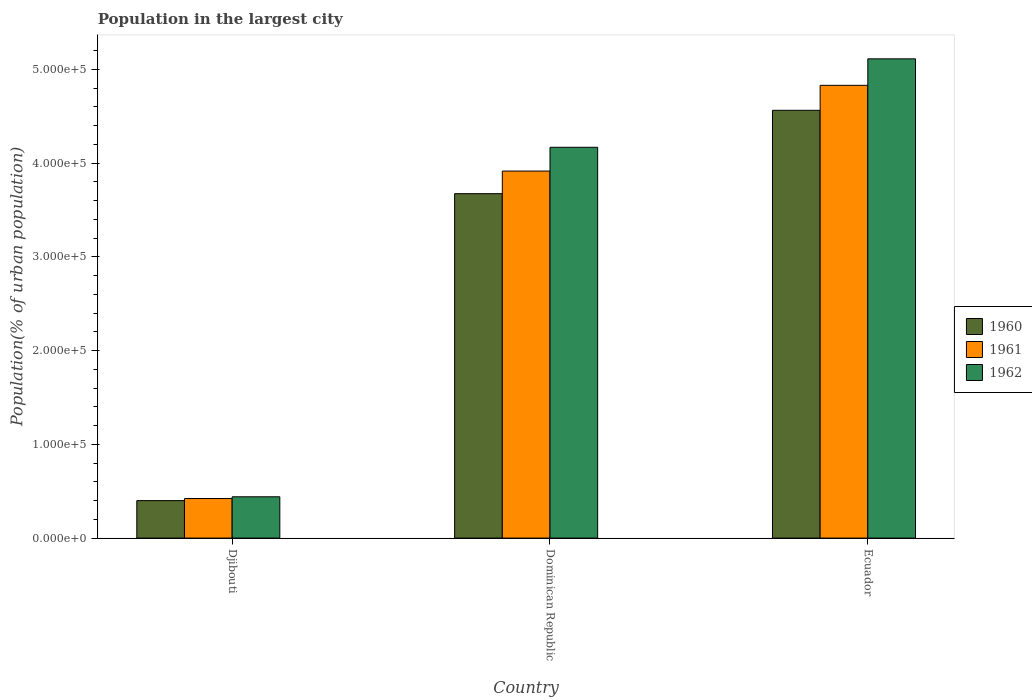How many different coloured bars are there?
Offer a terse response. 3. How many bars are there on the 3rd tick from the left?
Offer a terse response. 3. How many bars are there on the 2nd tick from the right?
Keep it short and to the point. 3. What is the label of the 1st group of bars from the left?
Provide a short and direct response. Djibouti. What is the population in the largest city in 1960 in Dominican Republic?
Ensure brevity in your answer.  3.67e+05. Across all countries, what is the maximum population in the largest city in 1960?
Give a very brief answer. 4.56e+05. Across all countries, what is the minimum population in the largest city in 1960?
Provide a short and direct response. 4.00e+04. In which country was the population in the largest city in 1962 maximum?
Make the answer very short. Ecuador. In which country was the population in the largest city in 1962 minimum?
Provide a succinct answer. Djibouti. What is the total population in the largest city in 1960 in the graph?
Keep it short and to the point. 8.64e+05. What is the difference between the population in the largest city in 1960 in Dominican Republic and that in Ecuador?
Keep it short and to the point. -8.89e+04. What is the difference between the population in the largest city in 1962 in Dominican Republic and the population in the largest city in 1961 in Djibouti?
Your response must be concise. 3.75e+05. What is the average population in the largest city in 1960 per country?
Your answer should be compact. 2.88e+05. What is the difference between the population in the largest city of/in 1960 and population in the largest city of/in 1961 in Dominican Republic?
Offer a very short reply. -2.41e+04. In how many countries, is the population in the largest city in 1960 greater than 200000 %?
Ensure brevity in your answer.  2. What is the ratio of the population in the largest city in 1960 in Dominican Republic to that in Ecuador?
Your answer should be very brief. 0.81. Is the population in the largest city in 1962 in Djibouti less than that in Dominican Republic?
Your answer should be compact. Yes. Is the difference between the population in the largest city in 1960 in Djibouti and Dominican Republic greater than the difference between the population in the largest city in 1961 in Djibouti and Dominican Republic?
Ensure brevity in your answer.  Yes. What is the difference between the highest and the second highest population in the largest city in 1960?
Offer a terse response. -8.89e+04. What is the difference between the highest and the lowest population in the largest city in 1960?
Your answer should be very brief. 4.16e+05. In how many countries, is the population in the largest city in 1960 greater than the average population in the largest city in 1960 taken over all countries?
Make the answer very short. 2. Is the sum of the population in the largest city in 1960 in Djibouti and Ecuador greater than the maximum population in the largest city in 1962 across all countries?
Give a very brief answer. No. What does the 3rd bar from the left in Ecuador represents?
Give a very brief answer. 1962. What does the 1st bar from the right in Djibouti represents?
Give a very brief answer. 1962. Is it the case that in every country, the sum of the population in the largest city in 1960 and population in the largest city in 1961 is greater than the population in the largest city in 1962?
Provide a succinct answer. Yes. Are all the bars in the graph horizontal?
Ensure brevity in your answer.  No. What is the difference between two consecutive major ticks on the Y-axis?
Offer a very short reply. 1.00e+05. Does the graph contain grids?
Ensure brevity in your answer.  No. Where does the legend appear in the graph?
Give a very brief answer. Center right. What is the title of the graph?
Offer a terse response. Population in the largest city. What is the label or title of the X-axis?
Your answer should be compact. Country. What is the label or title of the Y-axis?
Give a very brief answer. Population(% of urban population). What is the Population(% of urban population) in 1960 in Djibouti?
Provide a short and direct response. 4.00e+04. What is the Population(% of urban population) in 1961 in Djibouti?
Your answer should be very brief. 4.22e+04. What is the Population(% of urban population) in 1962 in Djibouti?
Keep it short and to the point. 4.40e+04. What is the Population(% of urban population) in 1960 in Dominican Republic?
Keep it short and to the point. 3.67e+05. What is the Population(% of urban population) in 1961 in Dominican Republic?
Offer a very short reply. 3.91e+05. What is the Population(% of urban population) of 1962 in Dominican Republic?
Offer a terse response. 4.17e+05. What is the Population(% of urban population) in 1960 in Ecuador?
Your answer should be compact. 4.56e+05. What is the Population(% of urban population) in 1961 in Ecuador?
Offer a very short reply. 4.83e+05. What is the Population(% of urban population) in 1962 in Ecuador?
Your answer should be very brief. 5.11e+05. Across all countries, what is the maximum Population(% of urban population) of 1960?
Give a very brief answer. 4.56e+05. Across all countries, what is the maximum Population(% of urban population) in 1961?
Make the answer very short. 4.83e+05. Across all countries, what is the maximum Population(% of urban population) of 1962?
Give a very brief answer. 5.11e+05. Across all countries, what is the minimum Population(% of urban population) in 1960?
Offer a terse response. 4.00e+04. Across all countries, what is the minimum Population(% of urban population) in 1961?
Your answer should be compact. 4.22e+04. Across all countries, what is the minimum Population(% of urban population) of 1962?
Ensure brevity in your answer.  4.40e+04. What is the total Population(% of urban population) of 1960 in the graph?
Keep it short and to the point. 8.64e+05. What is the total Population(% of urban population) of 1961 in the graph?
Your response must be concise. 9.17e+05. What is the total Population(% of urban population) in 1962 in the graph?
Your response must be concise. 9.72e+05. What is the difference between the Population(% of urban population) in 1960 in Djibouti and that in Dominican Republic?
Provide a succinct answer. -3.27e+05. What is the difference between the Population(% of urban population) in 1961 in Djibouti and that in Dominican Republic?
Your answer should be very brief. -3.49e+05. What is the difference between the Population(% of urban population) of 1962 in Djibouti and that in Dominican Republic?
Your answer should be very brief. -3.73e+05. What is the difference between the Population(% of urban population) in 1960 in Djibouti and that in Ecuador?
Make the answer very short. -4.16e+05. What is the difference between the Population(% of urban population) in 1961 in Djibouti and that in Ecuador?
Provide a short and direct response. -4.41e+05. What is the difference between the Population(% of urban population) of 1962 in Djibouti and that in Ecuador?
Your answer should be compact. -4.67e+05. What is the difference between the Population(% of urban population) in 1960 in Dominican Republic and that in Ecuador?
Ensure brevity in your answer.  -8.89e+04. What is the difference between the Population(% of urban population) in 1961 in Dominican Republic and that in Ecuador?
Provide a succinct answer. -9.14e+04. What is the difference between the Population(% of urban population) of 1962 in Dominican Republic and that in Ecuador?
Provide a succinct answer. -9.43e+04. What is the difference between the Population(% of urban population) in 1960 in Djibouti and the Population(% of urban population) in 1961 in Dominican Republic?
Ensure brevity in your answer.  -3.51e+05. What is the difference between the Population(% of urban population) of 1960 in Djibouti and the Population(% of urban population) of 1962 in Dominican Republic?
Offer a terse response. -3.77e+05. What is the difference between the Population(% of urban population) in 1961 in Djibouti and the Population(% of urban population) in 1962 in Dominican Republic?
Keep it short and to the point. -3.75e+05. What is the difference between the Population(% of urban population) of 1960 in Djibouti and the Population(% of urban population) of 1961 in Ecuador?
Your answer should be very brief. -4.43e+05. What is the difference between the Population(% of urban population) of 1960 in Djibouti and the Population(% of urban population) of 1962 in Ecuador?
Ensure brevity in your answer.  -4.71e+05. What is the difference between the Population(% of urban population) of 1961 in Djibouti and the Population(% of urban population) of 1962 in Ecuador?
Make the answer very short. -4.69e+05. What is the difference between the Population(% of urban population) in 1960 in Dominican Republic and the Population(% of urban population) in 1961 in Ecuador?
Provide a short and direct response. -1.16e+05. What is the difference between the Population(% of urban population) in 1960 in Dominican Republic and the Population(% of urban population) in 1962 in Ecuador?
Your answer should be compact. -1.44e+05. What is the difference between the Population(% of urban population) of 1961 in Dominican Republic and the Population(% of urban population) of 1962 in Ecuador?
Provide a short and direct response. -1.20e+05. What is the average Population(% of urban population) in 1960 per country?
Provide a succinct answer. 2.88e+05. What is the average Population(% of urban population) of 1961 per country?
Offer a terse response. 3.06e+05. What is the average Population(% of urban population) in 1962 per country?
Keep it short and to the point. 3.24e+05. What is the difference between the Population(% of urban population) of 1960 and Population(% of urban population) of 1961 in Djibouti?
Ensure brevity in your answer.  -2241. What is the difference between the Population(% of urban population) of 1960 and Population(% of urban population) of 1962 in Djibouti?
Your response must be concise. -4084. What is the difference between the Population(% of urban population) in 1961 and Population(% of urban population) in 1962 in Djibouti?
Your response must be concise. -1843. What is the difference between the Population(% of urban population) in 1960 and Population(% of urban population) in 1961 in Dominican Republic?
Provide a short and direct response. -2.41e+04. What is the difference between the Population(% of urban population) in 1960 and Population(% of urban population) in 1962 in Dominican Republic?
Your answer should be compact. -4.95e+04. What is the difference between the Population(% of urban population) in 1961 and Population(% of urban population) in 1962 in Dominican Republic?
Make the answer very short. -2.54e+04. What is the difference between the Population(% of urban population) of 1960 and Population(% of urban population) of 1961 in Ecuador?
Your answer should be very brief. -2.66e+04. What is the difference between the Population(% of urban population) in 1960 and Population(% of urban population) in 1962 in Ecuador?
Offer a terse response. -5.49e+04. What is the difference between the Population(% of urban population) of 1961 and Population(% of urban population) of 1962 in Ecuador?
Provide a short and direct response. -2.82e+04. What is the ratio of the Population(% of urban population) in 1960 in Djibouti to that in Dominican Republic?
Make the answer very short. 0.11. What is the ratio of the Population(% of urban population) in 1961 in Djibouti to that in Dominican Republic?
Give a very brief answer. 0.11. What is the ratio of the Population(% of urban population) in 1962 in Djibouti to that in Dominican Republic?
Give a very brief answer. 0.11. What is the ratio of the Population(% of urban population) of 1960 in Djibouti to that in Ecuador?
Offer a very short reply. 0.09. What is the ratio of the Population(% of urban population) of 1961 in Djibouti to that in Ecuador?
Offer a terse response. 0.09. What is the ratio of the Population(% of urban population) of 1962 in Djibouti to that in Ecuador?
Ensure brevity in your answer.  0.09. What is the ratio of the Population(% of urban population) of 1960 in Dominican Republic to that in Ecuador?
Offer a very short reply. 0.81. What is the ratio of the Population(% of urban population) of 1961 in Dominican Republic to that in Ecuador?
Your answer should be compact. 0.81. What is the ratio of the Population(% of urban population) in 1962 in Dominican Republic to that in Ecuador?
Give a very brief answer. 0.82. What is the difference between the highest and the second highest Population(% of urban population) of 1960?
Ensure brevity in your answer.  8.89e+04. What is the difference between the highest and the second highest Population(% of urban population) of 1961?
Give a very brief answer. 9.14e+04. What is the difference between the highest and the second highest Population(% of urban population) in 1962?
Ensure brevity in your answer.  9.43e+04. What is the difference between the highest and the lowest Population(% of urban population) in 1960?
Provide a short and direct response. 4.16e+05. What is the difference between the highest and the lowest Population(% of urban population) in 1961?
Your response must be concise. 4.41e+05. What is the difference between the highest and the lowest Population(% of urban population) in 1962?
Give a very brief answer. 4.67e+05. 